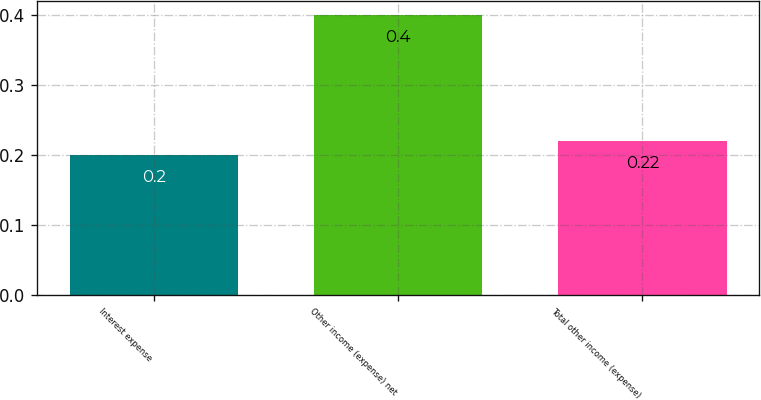Convert chart to OTSL. <chart><loc_0><loc_0><loc_500><loc_500><bar_chart><fcel>Interest expense<fcel>Other income (expense) net<fcel>Total other income (expense)<nl><fcel>0.2<fcel>0.4<fcel>0.22<nl></chart> 